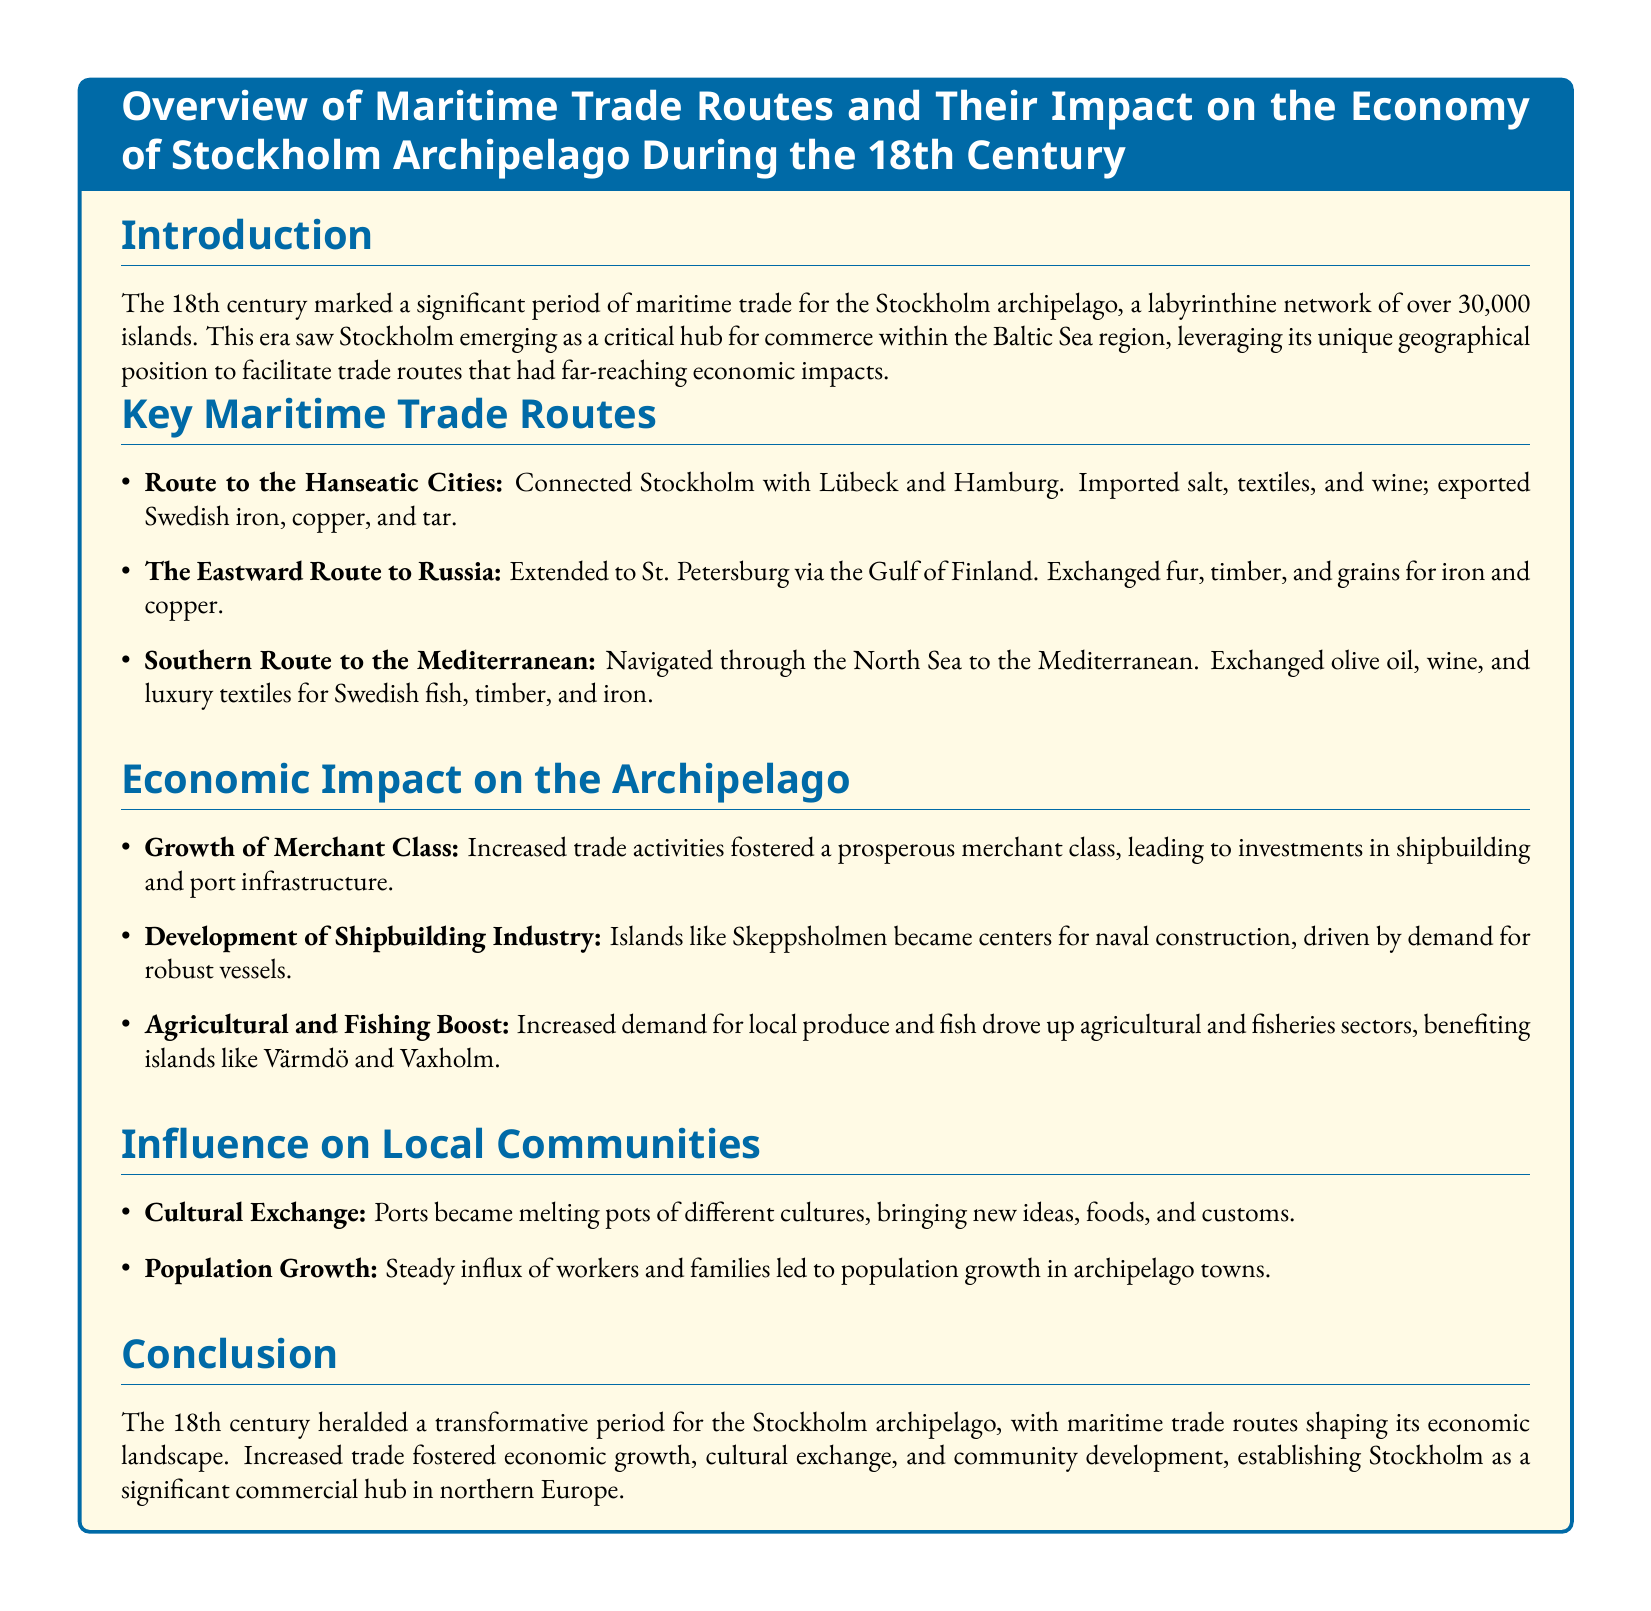What was a key maritime trade route connected to Lübeck and Hamburg? The route is important for trade connections within the region, specifically linking Stockholm with the Hanseatic cities.
Answer: Route to the Hanseatic Cities What types of goods were imported through the Eastward Route to Russia? This question identifies specific commodities exchanged during trade with Russia, emphasizing the economic interactions.
Answer: Fur, timber, and grains Which islands became centers for naval construction? This highlights specific locations within the archipelago that experienced industrial growth due to trade demands.
Answer: Skeppsholmen What effect did maritime trade have on the merchant class? This explores the broader economic implications of trade on social structures within the archipelago.
Answer: Prosperous merchant class What did increased demand for local produce and fish boost? This relates to the specific sectors that benefited from trade, indicating economic growth areas.
Answer: Agricultural and fisheries sectors Which cultural aspect increased due to trade in the archipelago? This illustrates the social changes resulting from increased interactions among different communities.
Answer: Cultural Exchange What major economic role did Stockholm play during the 18th century? This question summarizes Stockholm's position in the regional economy.
Answer: Critical hub for commerce What was the primary maritime trade route to the Mediterranean? This name is important to understand the geographical scope of trade connections for the archipelago.
Answer: Southern Route to the Mediterranean How did population change as a result of maritime trade? This examines demographic shifts correlated with economic activities in the area.
Answer: Population growth 